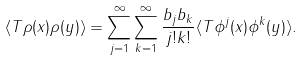Convert formula to latex. <formula><loc_0><loc_0><loc_500><loc_500>\langle T \rho ( x ) \rho ( y ) \rangle & = \sum _ { j = 1 } ^ { \infty } \sum _ { k = 1 } ^ { \infty } \frac { b _ { j } b _ { k } } { j ! k ! } \langle T \phi ^ { j } ( x ) \phi ^ { k } ( y ) \rangle .</formula> 